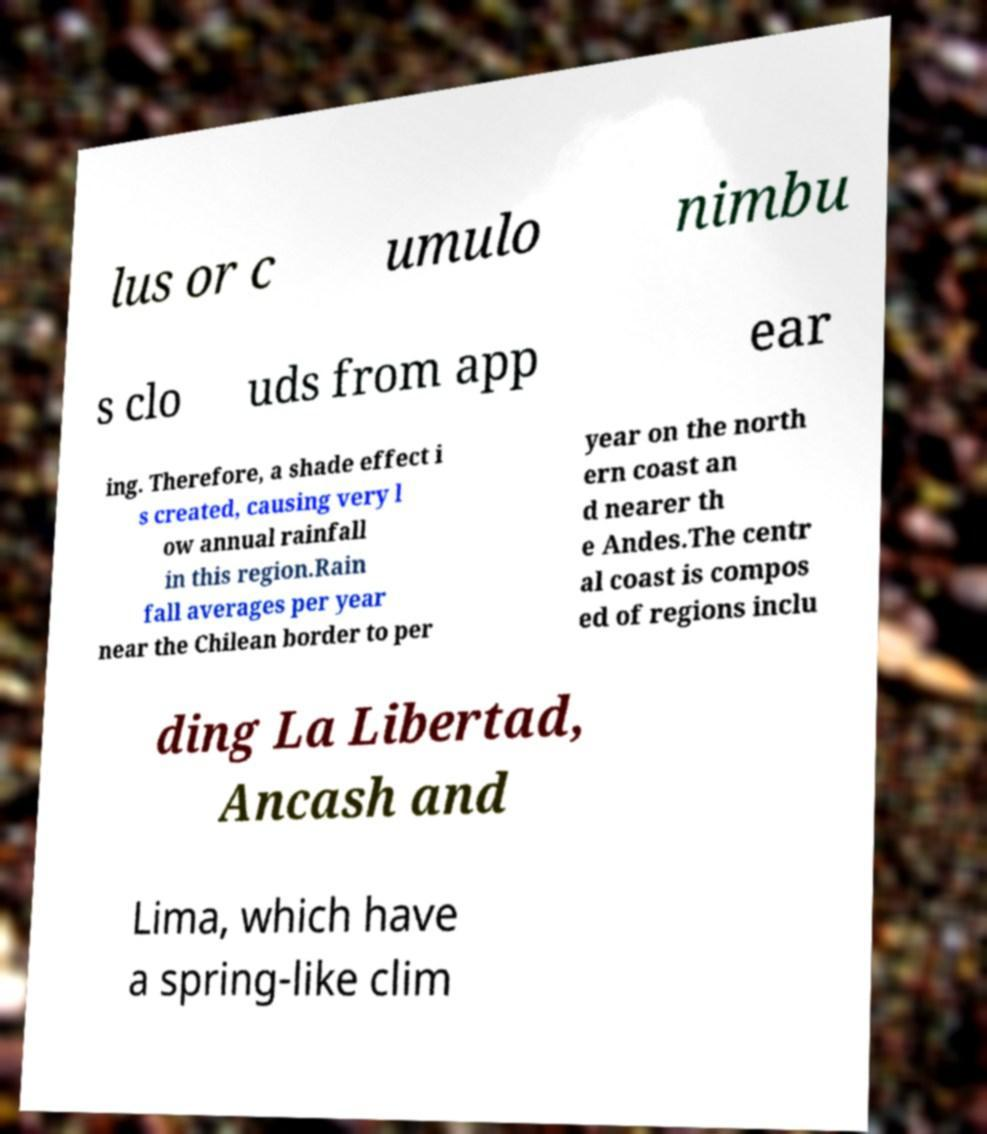There's text embedded in this image that I need extracted. Can you transcribe it verbatim? lus or c umulo nimbu s clo uds from app ear ing. Therefore, a shade effect i s created, causing very l ow annual rainfall in this region.Rain fall averages per year near the Chilean border to per year on the north ern coast an d nearer th e Andes.The centr al coast is compos ed of regions inclu ding La Libertad, Ancash and Lima, which have a spring-like clim 